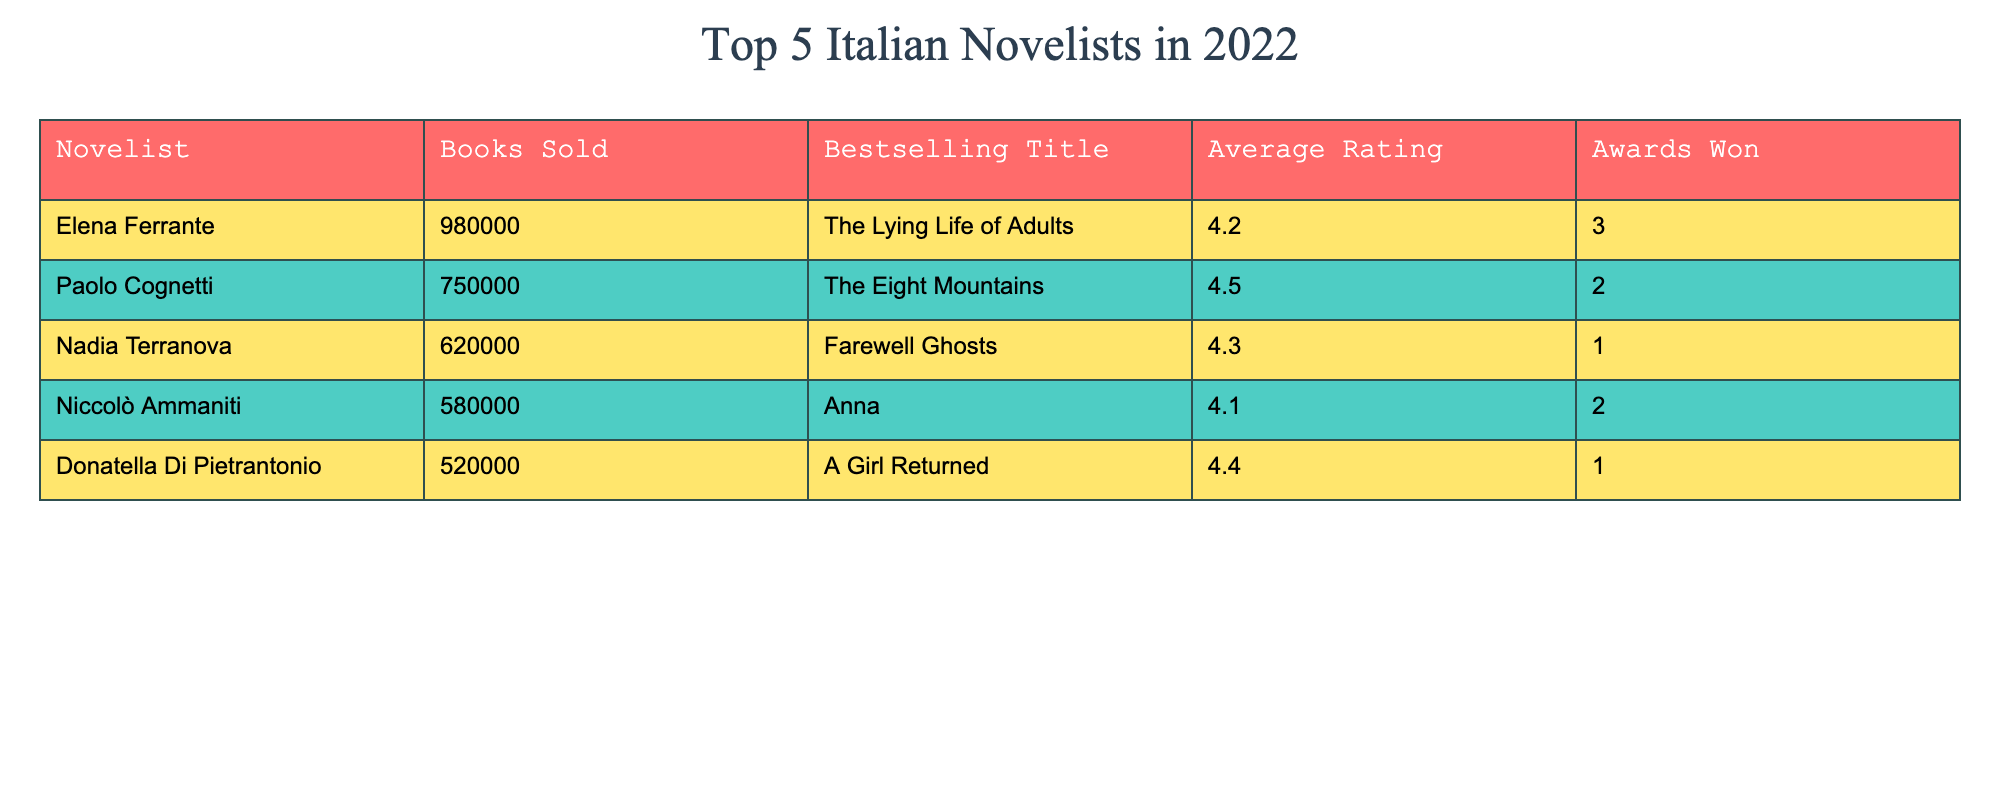What is the bestselling title of Paolo Cognetti? The table lists the bestselling titles for each novelist. For Paolo Cognetti, the bestselling title is "The Eight Mountains."
Answer: "The Eight Mountains" How many books did Nadia Terranova sell in 2022? The table indicates that Nadia Terranova sold 620,000 books in 2022.
Answer: 620000 What is the average rating of Donatella Di Pietrantonio's bestselling title? According to the data, Donatella Di Pietrantonio has an average rating of 4.4 for "A Girl Returned."
Answer: 4.4 Which novelist won the most awards? The table shows that Elena Ferrante won 3 awards, which is the highest among all listed novelists.
Answer: Elena Ferrante If we sum the books sold by Niccolò Ammaniti and Donatella Di Pietrantonio, how many books were sold in total? Niccolò Ammaniti sold 580,000 books and Donatella Di Pietrantonio sold 520,000 books. Adding these gives 580,000 + 520,000 = 1,100,000.
Answer: 1100000 Is it true that Nadia Terranova has a higher average rating than Niccolò Ammaniti? Nadia Terranova has an average rating of 4.3 while Niccolò Ammaniti's average rating is 4.1. Since 4.3 is greater than 4.1, the statement is true.
Answer: Yes What is the difference in books sold between the top-selling novelist and the lowest-selling novelist? The top-selling novelist is Elena Ferrante with 980,000 books and the lowest is Donatella Di Pietrantonio with 520,000. The difference is 980,000 - 520,000 = 460,000.
Answer: 460000 What is the average number of books sold by the top 5 Italian novelists? To find the average, we sum the books sold: 980,000 + 750,000 + 620,000 + 580,000 + 520,000 = 3,450,000. Then we divide by 5 (the number of novelists): 3,450,000 / 5 = 690,000.
Answer: 690000 Which novelist has an average rating less than 4.3? The table shows that Niccolò Ammaniti has an average rating of 4.1, which is less than 4.3.
Answer: Niccolò Ammaniti What is the combined number of awards won by the top three novelists? The top three novelists based on sales are Elena Ferrante (3 awards), Paolo Cognetti (2 awards), and Nadia Terranova (1 award). Adding these together gives 3 + 2 + 1 = 6 awards.
Answer: 6 